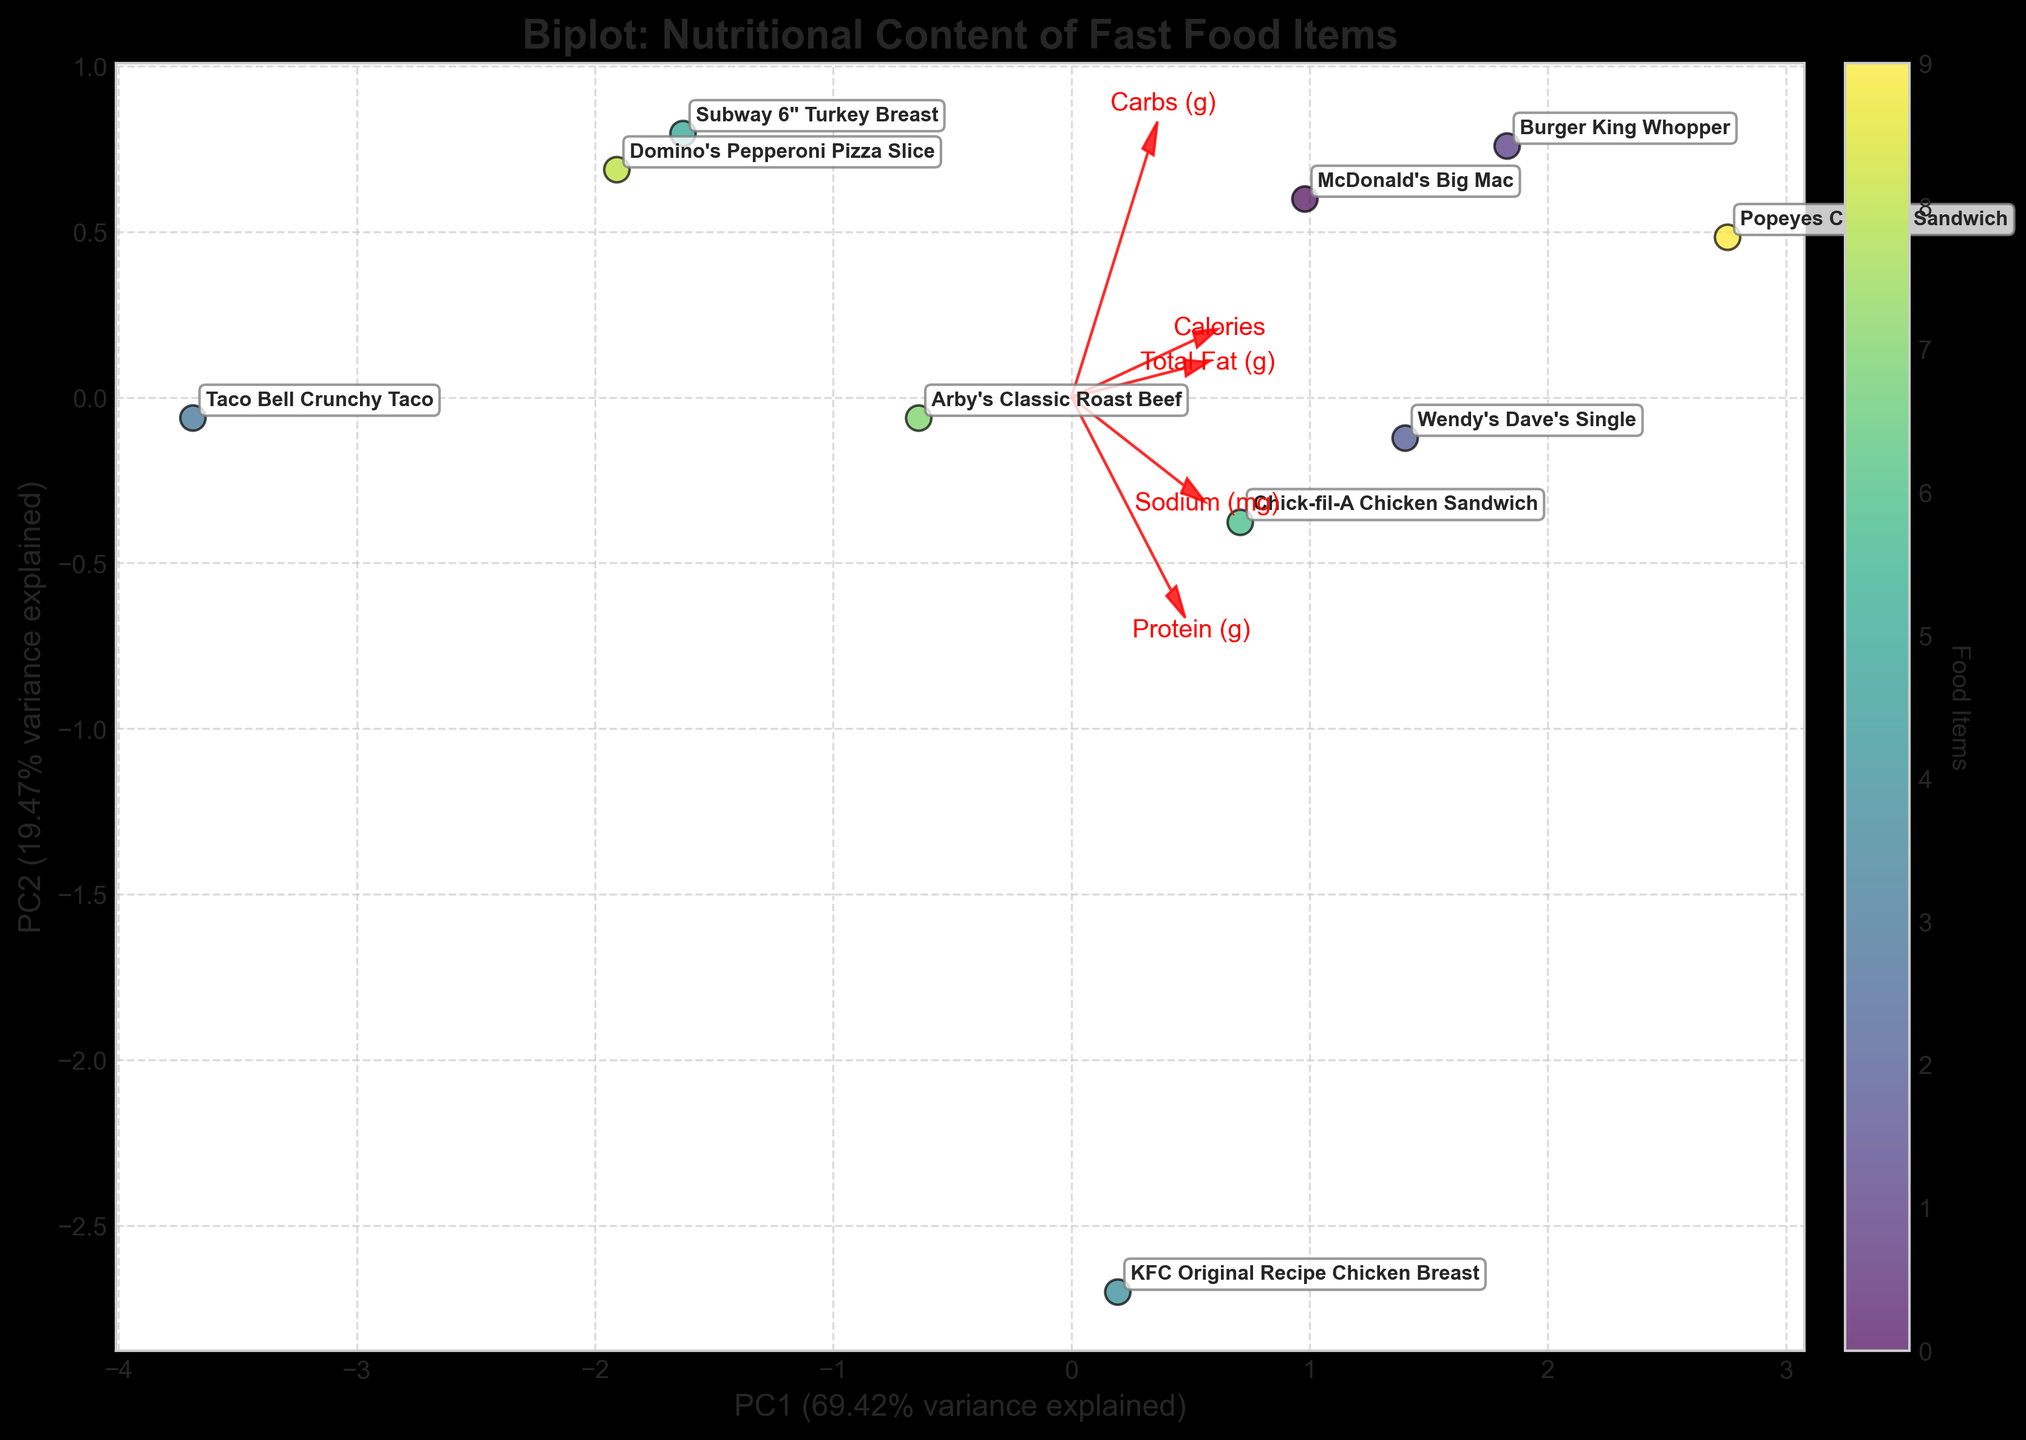Which food item has the highest value on PC1? The label of the food item with the highest value on the PC1 axis will be farthest to the right. Popeyes Chicken Sandwich is positioned farthest along the PC1 axis.
Answer: Popeyes Chicken Sandwich Which feature is closest to the PC2-axis arrow? The feature vector arrow that is closest to the vertical axis (PC2) represents the feature Sodium (mg).
Answer: Sodium (mg) Which two food items are closest to each other in the plot? By observing the plot, Arby's Classic Roast Beef and Domino's Pepperoni Pizza Slice are the closest to each other.
Answer: Arby's Classic Roast Beef and Domino's Pepperoni Pizza Slice What percentage of the variance in nutritional content is explained by PC1? The x-axis label shows the percentage of variance explained by PC1. From the axis label, 59.20% of the variance is explained by PC1.
Answer: 59.20% Which feature vector points most strongly in the direction of high-calorie items? The feature vector arrow representing 'Calories' points closest to the direction of food items with high-calorie values. This means the 'Calories' vector aligns with where Big Mac, Whopper, and Dave's Single are situated.
Answer: Calories How do McDonald's Big Mac and Subway 6" Turkey Breast compare in terms of nutritional content based on their positions in the plot? McDonald's Big Mac is positioned more toward higher values on PC1 compared to Subway 6" Turkey Breast. Based on PCA, this means Big Mac has higher values in features like calories, total fat, sodium, carbs, and protein. Subway 6" Turkey Breast has distinctly lower values in these features, as indicated by its position.
Answer: Big Mac has higher values in most features compared to Subway 6" Turkey Breast What is the predominant feature that contributes to the positioning of Chick-fil-A Chicken Sandwich on the biplot? The Chick-fil-A Chicken Sandwich is positioned where the Protein (g) feature vector significantly contributes. This sandwich has a relatively higher concentration of protein.
Answer: Protein (g) Which food item is positioned furthest to the left on PC1, and what does that signify? The item furthest to the left on PC1 is Taco Bell Crunchy Taco, indicating that it has the lowest combined values for features like calories, fat, sodium, carbs, and protein compared to other items.
Answer: Taco Bell Crunchy Taco What is indicated by the alignment of KFC Original Recipe Chicken Breast with the feature vector Sodium (mg)? KFC Original Recipe Chicken Breast aligns closely with the Sodium (mg) vector, meaning that sodium content significantly contributes to its nutritional profile.
Answer: Sodium (mg) 